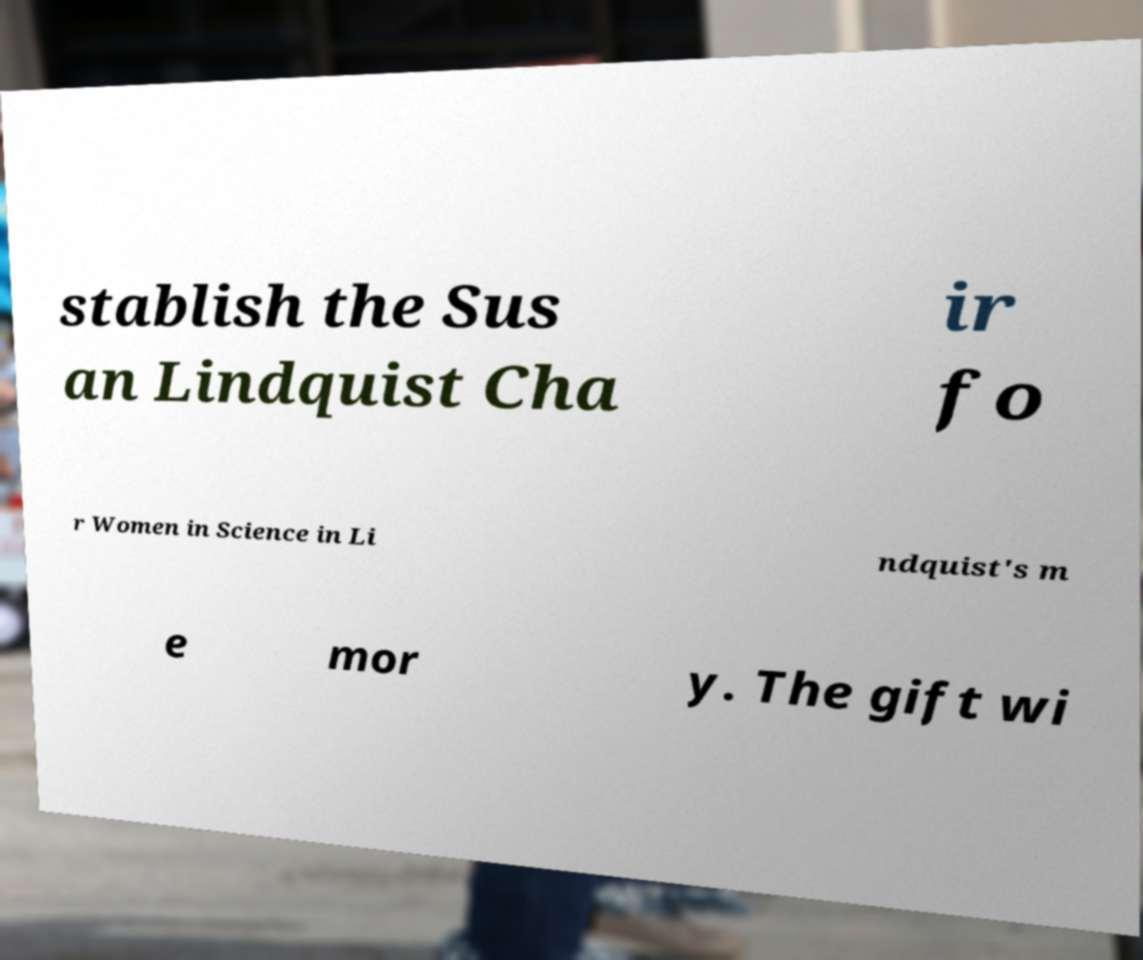Could you assist in decoding the text presented in this image and type it out clearly? stablish the Sus an Lindquist Cha ir fo r Women in Science in Li ndquist's m e mor y. The gift wi 